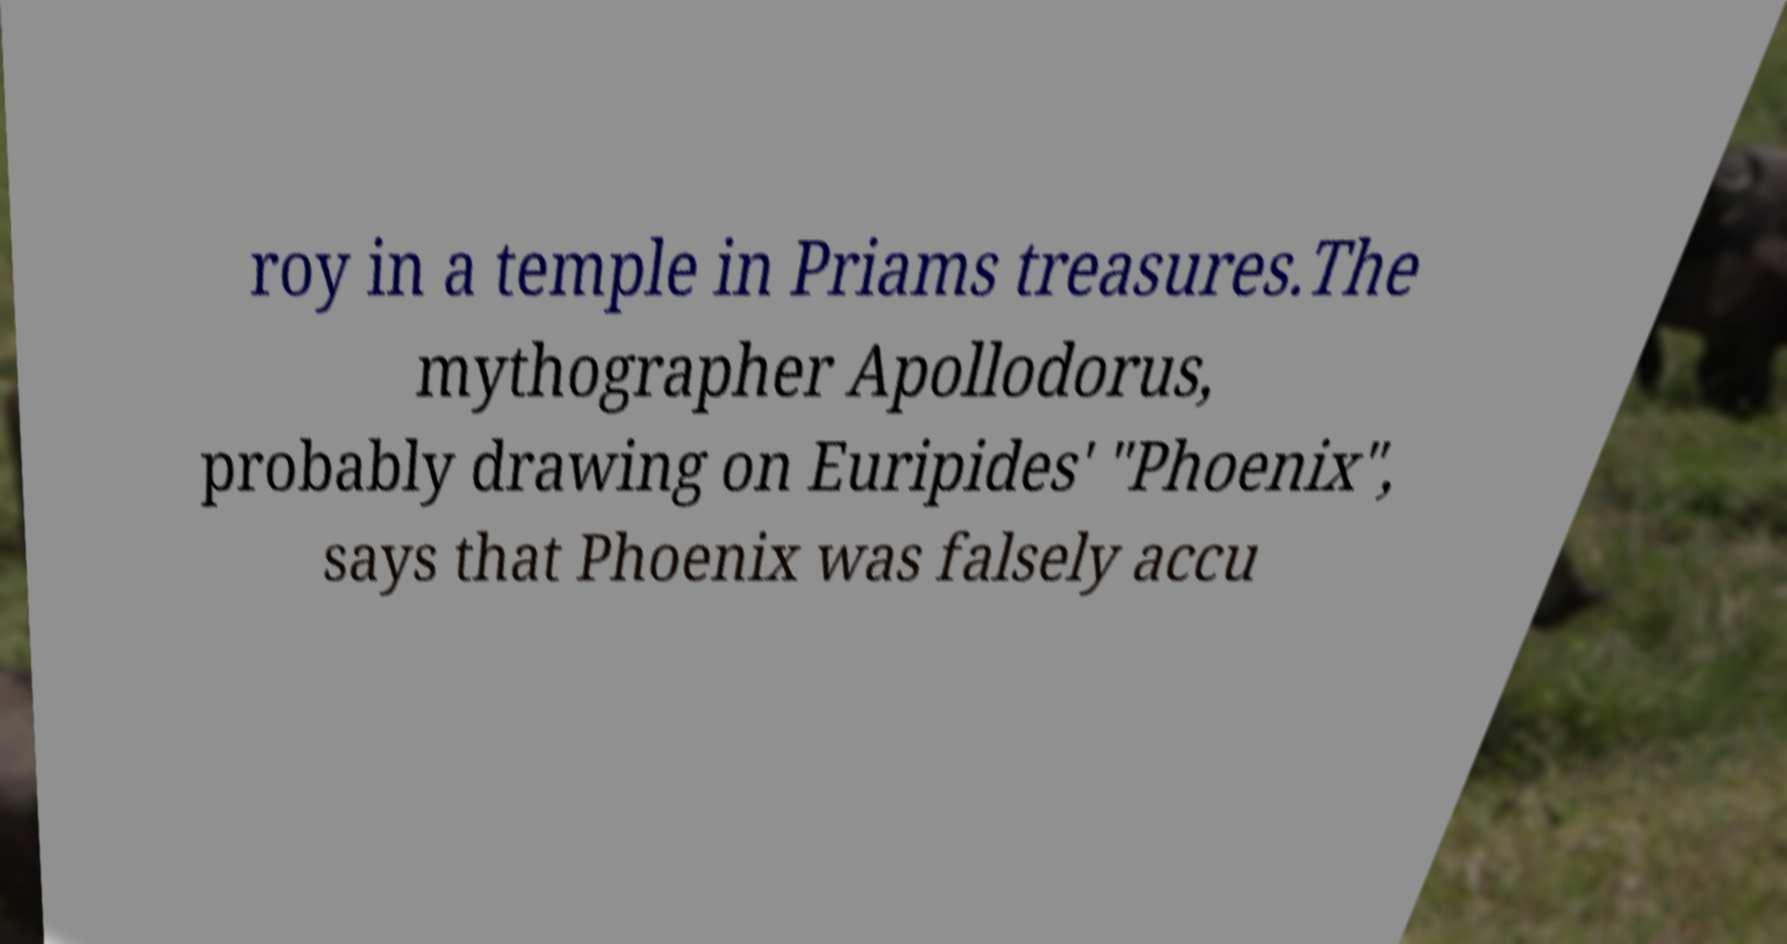There's text embedded in this image that I need extracted. Can you transcribe it verbatim? roy in a temple in Priams treasures.The mythographer Apollodorus, probably drawing on Euripides' "Phoenix", says that Phoenix was falsely accu 